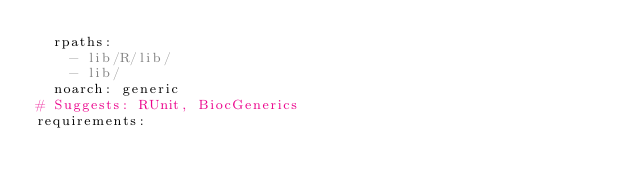Convert code to text. <code><loc_0><loc_0><loc_500><loc_500><_YAML_>  rpaths:
    - lib/R/lib/
    - lib/
  noarch: generic
# Suggests: RUnit, BiocGenerics
requirements:</code> 